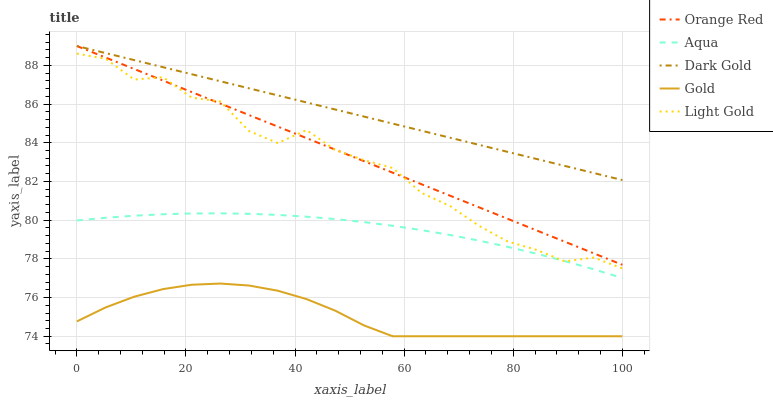Does Gold have the minimum area under the curve?
Answer yes or no. Yes. Does Dark Gold have the maximum area under the curve?
Answer yes or no. Yes. Does Aqua have the minimum area under the curve?
Answer yes or no. No. Does Aqua have the maximum area under the curve?
Answer yes or no. No. Is Dark Gold the smoothest?
Answer yes or no. Yes. Is Light Gold the roughest?
Answer yes or no. Yes. Is Aqua the smoothest?
Answer yes or no. No. Is Aqua the roughest?
Answer yes or no. No. Does Gold have the lowest value?
Answer yes or no. Yes. Does Aqua have the lowest value?
Answer yes or no. No. Does Dark Gold have the highest value?
Answer yes or no. Yes. Does Aqua have the highest value?
Answer yes or no. No. Is Gold less than Orange Red?
Answer yes or no. Yes. Is Dark Gold greater than Aqua?
Answer yes or no. Yes. Does Aqua intersect Light Gold?
Answer yes or no. Yes. Is Aqua less than Light Gold?
Answer yes or no. No. Is Aqua greater than Light Gold?
Answer yes or no. No. Does Gold intersect Orange Red?
Answer yes or no. No. 